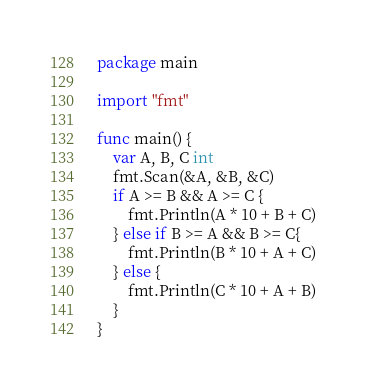Convert code to text. <code><loc_0><loc_0><loc_500><loc_500><_Go_>package main

import "fmt"

func main() {
    var A, B, C int
    fmt.Scan(&A, &B, &C)
    if A >= B && A >= C {
        fmt.Println(A * 10 + B + C)
    } else if B >= A && B >= C{
        fmt.Println(B * 10 + A + C)
    } else {
        fmt.Println(C * 10 + A + B)
    }
}
</code> 